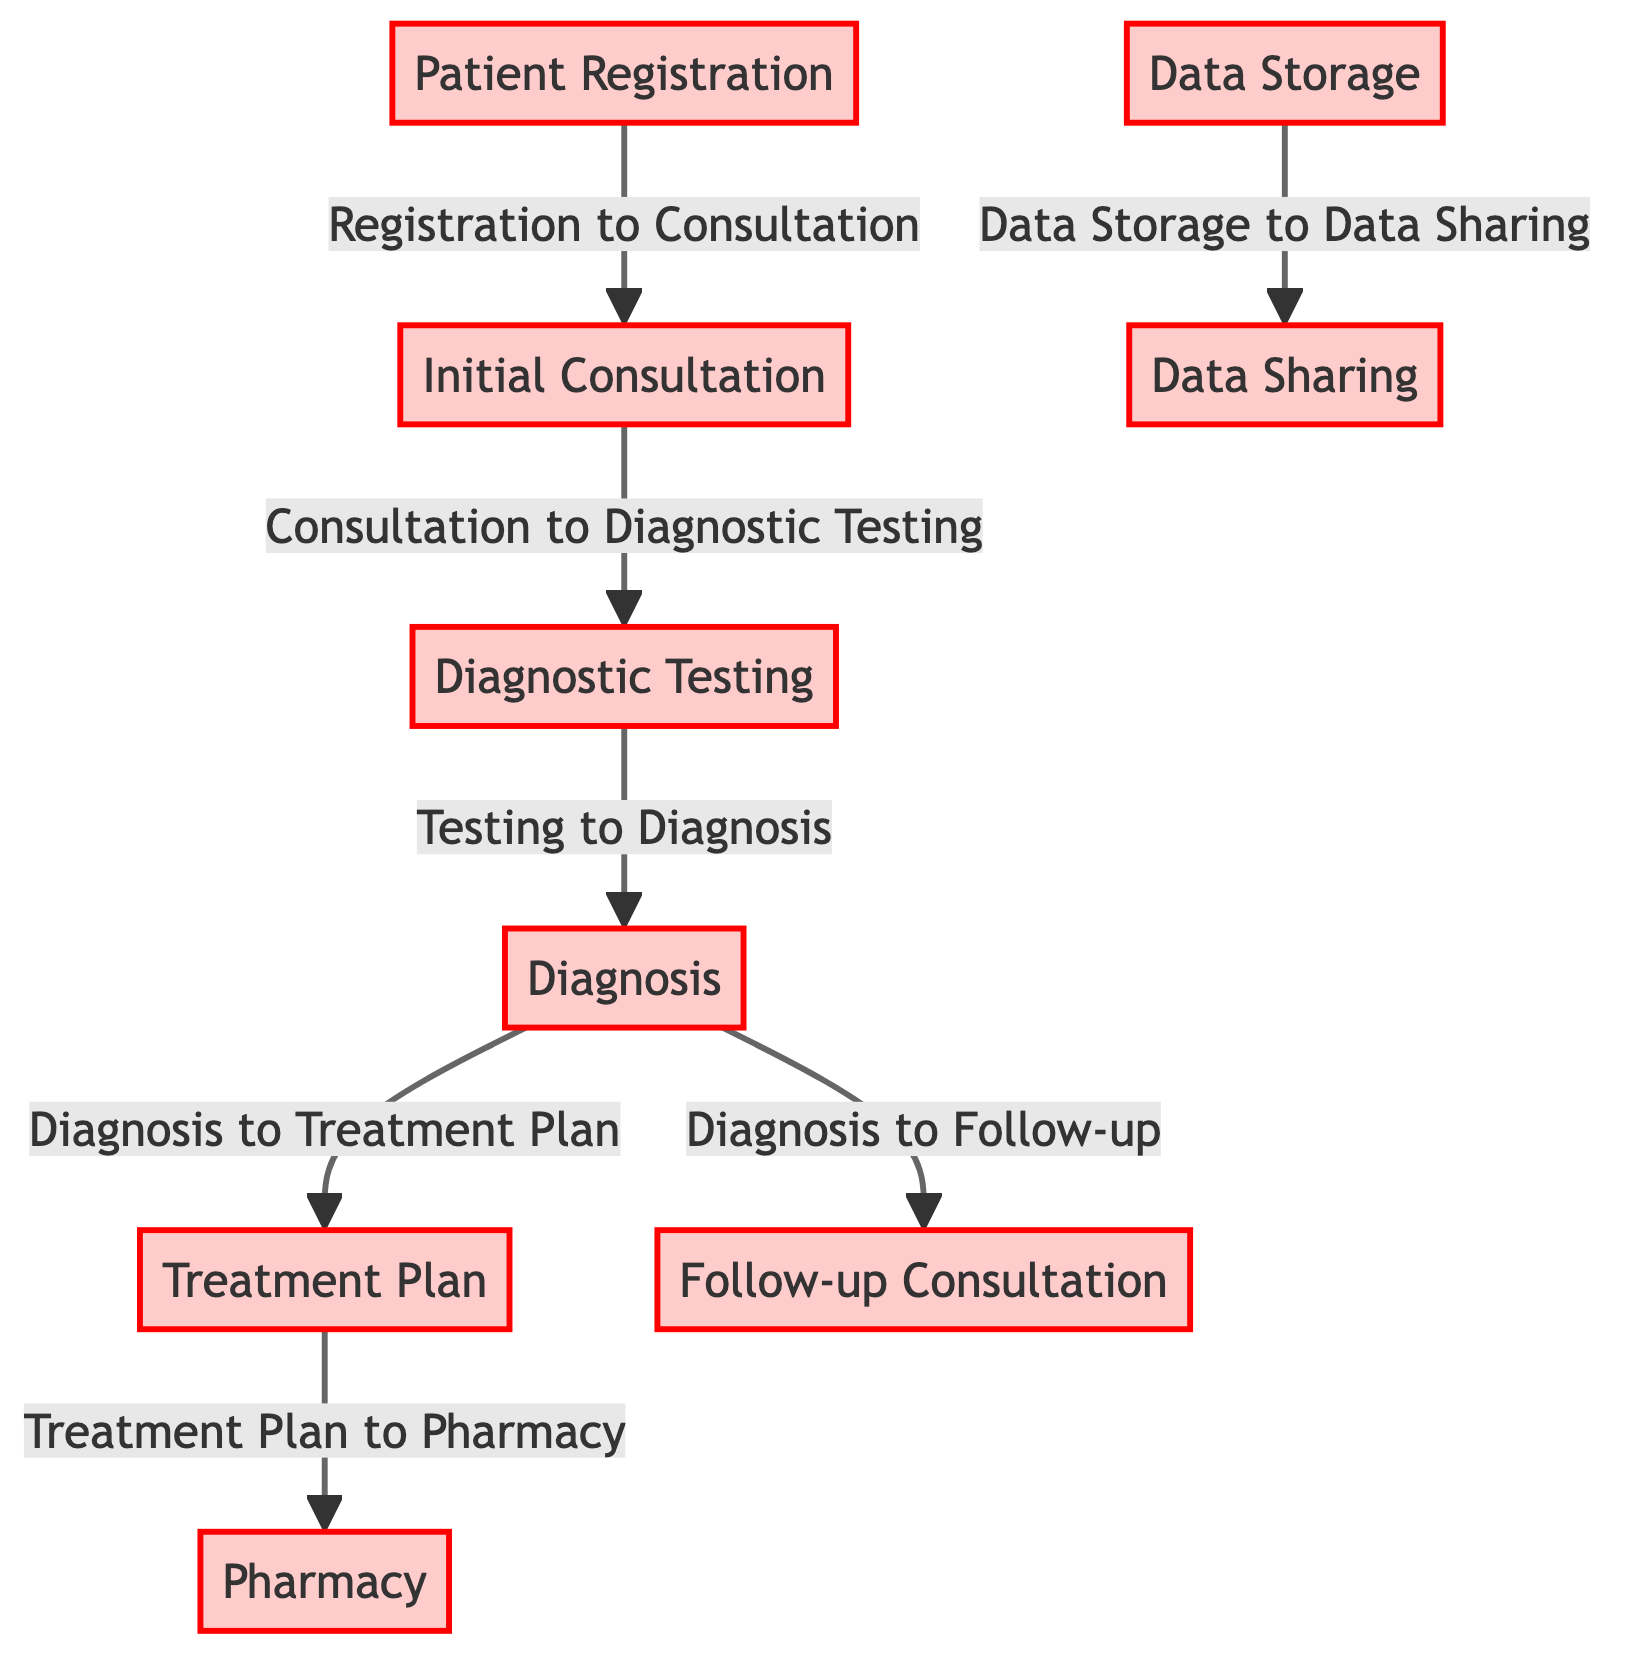What is the first step in the patient data flow? The diagram indicates that the first node is "Patient Registration," which captures initial patient data.
Answer: Patient Registration How many nodes are present in the diagram? By counting all unique steps listed in the diagram, there are a total of nine nodes represented in the flowchart.
Answer: Nine What follows the Initial Consultation in patient data flow? According to the diagram, the flow from "Initial Consultation" leads directly to "Diagnostic Testing."
Answer: Diagnostic Testing What is the primary vulnerability at the Diagnosis stage? The diagram identifies the vulnerability at this stage as "Diagnosis details and deliberations recorded digitally."
Answer: Diagnosis details and deliberations recorded digitally How many connections are made from the Diagnosis stage? The diagram shows that there are two connections that lead from the "Diagnosis" node—one to "Treatment Plan" and one to "Follow-up Consultation."
Answer: Two What type of data is stored after Diagnostic Testing? The diagram states that "Test results stored and shared through hospital information systems" indicating the type of data involved.
Answer: Test results Identify a vulnerability point during the treatment process. The diagram highlights a key vulnerability during the treatment stage as "Prescriptions and treatment plans digitally communicated to pharmacy."
Answer: Prescriptions and treatment plans digitally communicated to pharmacy Which node involves data storage vulnerability? The "Data Storage" node explicitly mentions that "Centralized storage of patient data vulnerable to breaches and unauthorized access," addressing its vulnerability.
Answer: Data Storage What kind of data transfer occurs at the Data Sharing stage? The diagram describes that data shared between different departments or with external specialists contains a risk, indicating that "Data transfer might be unsecured, risking exposure."
Answer: Data transfer might be unsecured, risking exposure How many stages include ongoing updates to patient data? The "Follow-up Consultation" stage mentions ongoing updates to patient EHR, but the only stage that directly communicates this is the Follow-up Consultation.
Answer: One 